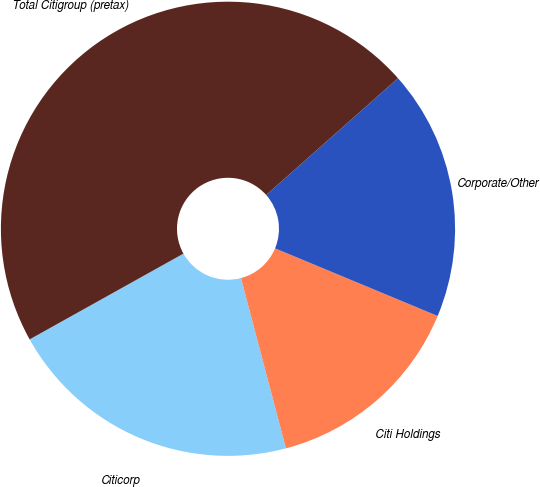Convert chart. <chart><loc_0><loc_0><loc_500><loc_500><pie_chart><fcel>Citicorp<fcel>Citi Holdings<fcel>Corporate/Other<fcel>Total Citigroup (pretax)<nl><fcel>21.01%<fcel>14.62%<fcel>17.81%<fcel>46.56%<nl></chart> 